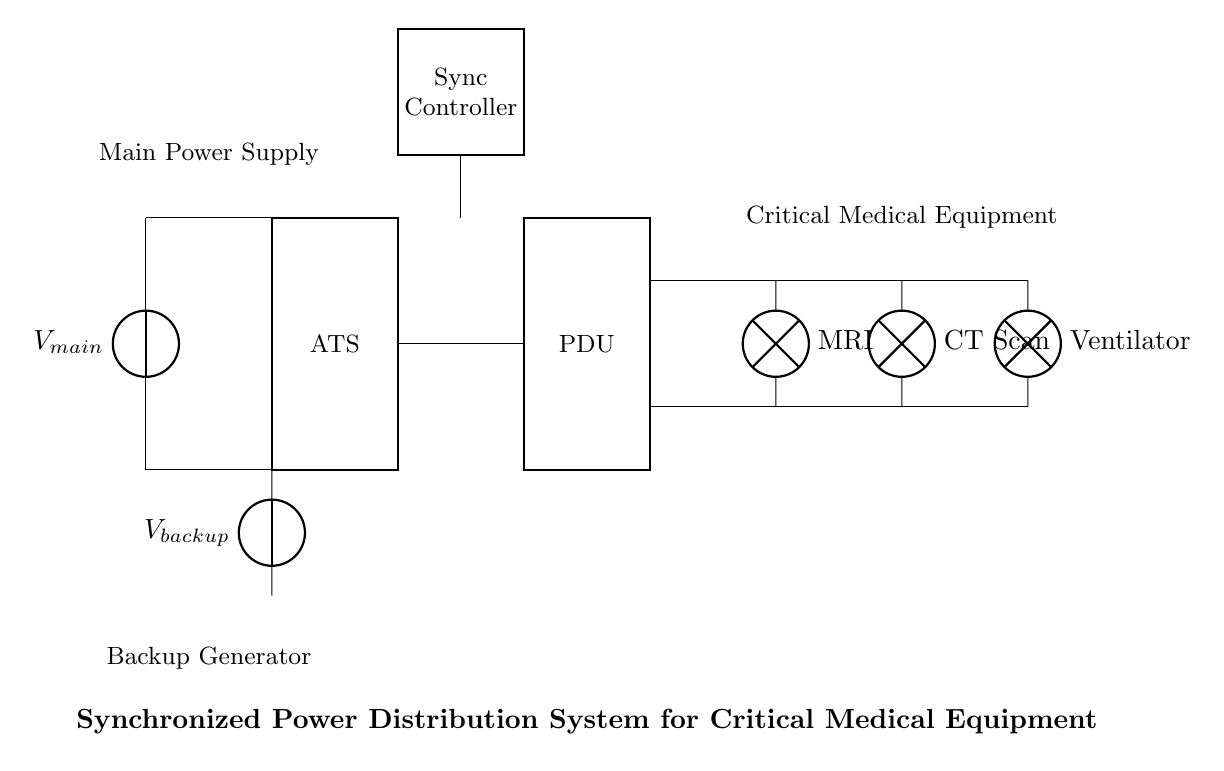What is the function of the Automatic Transfer Switch? The Automatic Transfer Switch (ATS) is used to switch between the main power source and the backup generator, ensuring continuous power supply to critical equipment.
Answer: Switches power sources What type of medical equipment is connected to this system? The circuit diagram indicates that MRI, CT Scan, and Ventilator are the types of critical medical equipment connected to the power distribution unit.
Answer: MRI, CT Scan, Ventilator What is the role of the Synchronization Controller? The Synchronization Controller is responsible for coordinating the operation of the power sources to ensure they are synchronously supplying power to avoid outages and ensure stability.
Answer: Coordinating power sources How many main power sources are present in this circuit? There are two main power sources: the main power supply and the backup generator, providing redundancy in case of power failure.
Answer: Two Where does the backup power come from? The backup power in this circuit is supplied by a backup generator, which activates when the main power source is unavailable.
Answer: Backup generator What do the terminals labeled "PDU" represent? The term "PDU" stands for Power Distribution Unit, which is responsible for distributing the electrical power to different connected medical equipment efficiently.
Answer: Power Distribution Unit How is the critical medical equipment connected to the power system? The critical medical equipment is connected to the power distribution unit, which distributes the necessary power to the equipment based on demand.
Answer: Through the Power Distribution Unit 